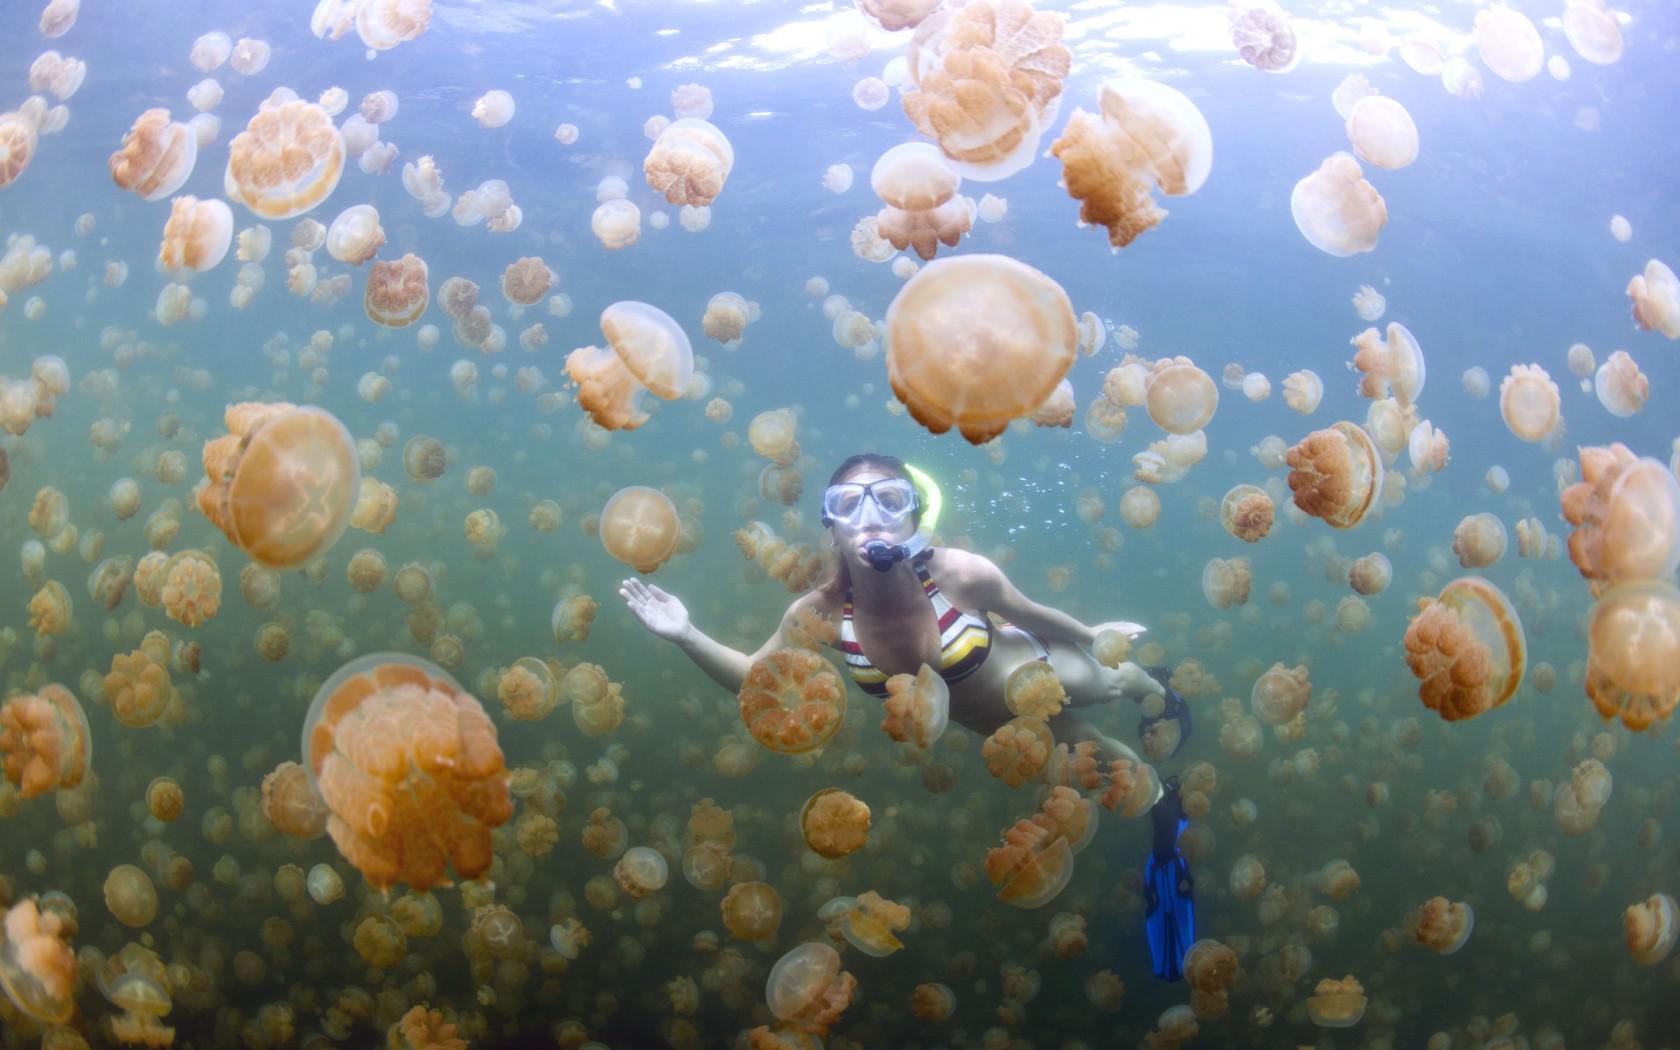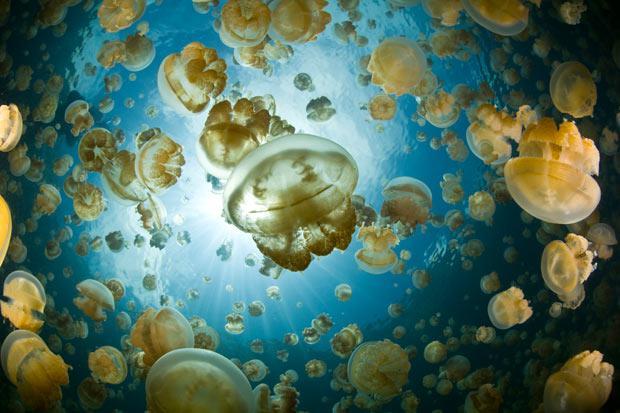The first image is the image on the left, the second image is the image on the right. For the images shown, is this caption "At least one image has jellyfish highlighted in pink." true? Answer yes or no. No. 